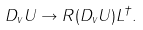<formula> <loc_0><loc_0><loc_500><loc_500>D _ { v } U \rightarrow R ( D _ { v } U ) L ^ { \dagger } .</formula> 